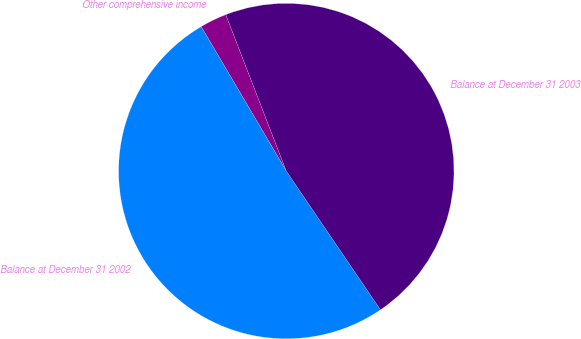Convert chart. <chart><loc_0><loc_0><loc_500><loc_500><pie_chart><fcel>Other comprehensive income<fcel>Balance at December 31 2002<fcel>Balance at December 31 2003<nl><fcel>2.6%<fcel>51.02%<fcel>46.38%<nl></chart> 